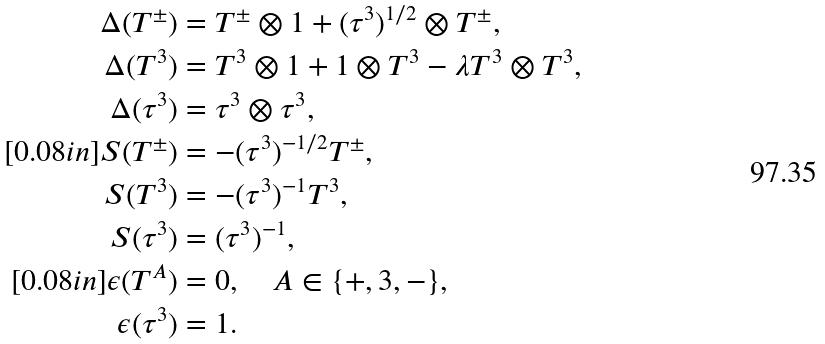Convert formula to latex. <formula><loc_0><loc_0><loc_500><loc_500>\Delta ( T ^ { \pm } ) & = T ^ { \pm } \otimes 1 + ( \tau ^ { 3 } ) ^ { 1 / 2 } \otimes T ^ { \pm } , \\ \Delta ( T ^ { 3 } ) & = T ^ { 3 } \otimes 1 + 1 \otimes T ^ { 3 } - \lambda T ^ { 3 } \otimes T ^ { 3 } , \\ \Delta ( \tau ^ { 3 } ) & = \tau ^ { 3 } \otimes \tau ^ { 3 } , \\ [ 0 . 0 8 i n ] S ( T ^ { \pm } ) & = - ( \tau ^ { 3 } ) ^ { - 1 / 2 } T ^ { \pm } , \\ S ( T ^ { 3 } ) & = - ( \tau ^ { 3 } ) ^ { - 1 } T ^ { 3 } , \\ S ( \tau ^ { 3 } ) & = ( \tau ^ { 3 } ) ^ { - 1 } , \\ [ 0 . 0 8 i n ] \epsilon ( T ^ { A } ) & = 0 , \quad A \in { \{ } + , 3 , - { \} } , \\ \epsilon ( \tau ^ { 3 } ) & = 1 .</formula> 